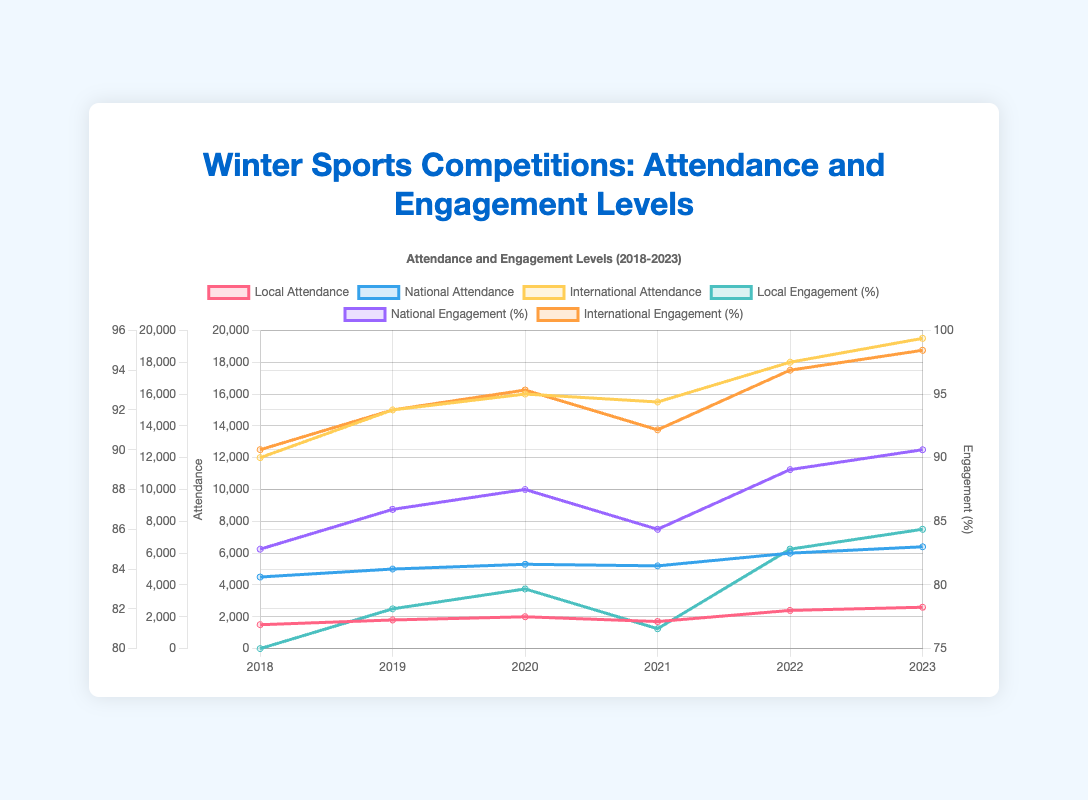What is the overall trend in local attendance from 2018 to 2023? The overall trend in local attendance shows an increase from 1500 in 2018 to 2600 in 2023, with a minor dip in 2021. This indicates a general upward trend despite a small drop in one year.
Answer: Increasing Which year had the highest national engagement? The engagement levels for each year are represented by the purple line. The highest point on this line occurs in 2023 where the national engagement level reaches 90%.
Answer: 2023 How does the international attendance in 2023 compare to that in 2018? Look at the yellow line representing international attendance. In 2018, the attendance is 12000, and in 2023, it is 19500. Therefore, 2023 has higher international attendance than 2018.
Answer: Higher Calculate the average local attendance over the six years. Sum the local attendance values for all years: 1500 + 1800 + 2000 + 1700 + 2400 + 2600 = 12000. Divide this sum by the number of years (6): 12000 / 6 = 2000.
Answer: 2000 Which competition level shows the highest rate of increase in engagement from 2018 to 2023? Calculate the increase in engagement for each level: Local: 86 - 80 = 6, National: 90 - 85 = 5, International: 95 - 90 = 5. Although all levels show an increase, Local's increase of 6 is the highest.
Answer: Local Which year experienced a decrease in both local attendance and engagement? Compare the values of local attendance and engagement between consecutive years. The year 2021 shows a drop in local attendance (1700) and engagement (81) compared to 2020 (2000 and 83 respectively).
Answer: 2021 What is the total national attendance across all years? Sum the national attendance values for all years: 4500 + 5000 + 5300 + 5200 + 6000 + 6400 = 32400.
Answer: 32400 Explain the relationship between international engagement and attendance trends from 2018 to 2023. Both international engagement and attendance show an upward trend. The engagement goes from 90% in 2018 to 95% in 2023, and attendance rises from 12000 to 19500. The steady growth reflects positive developments at the international competition level.
Answer: Both are increasing What's the difference between the highest and the lowest local engagements over the six years? Identify the highest and lowest local engagements: highest = 86 in 2023, lowest = 80 in 2018. The difference is 86 - 80 = 6.
Answer: 6 